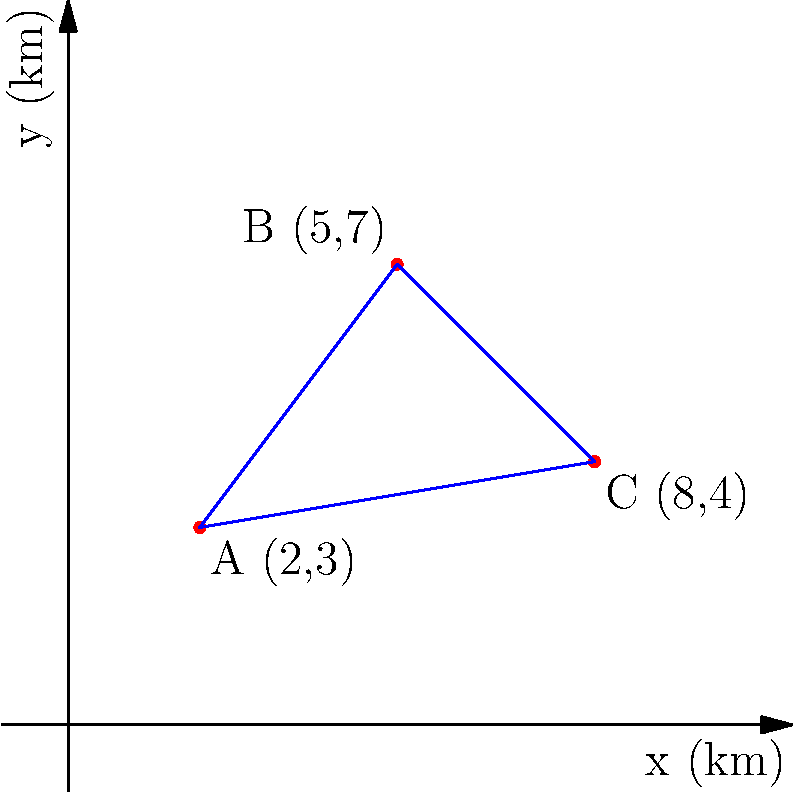Three archaeological sites (A, B, and C) have been discovered in a region of China. Their locations are plotted on a Cartesian coordinate system where each unit represents 1 km. Site A is at (2,3), B at (5,7), and C at (8,4). What is the area of the triangle formed by connecting these three sites, in square kilometers? To find the area of the triangle formed by the three archaeological sites, we can use the formula for the area of a triangle given the coordinates of its vertices:

Area = $\frac{1}{2}|x_1(y_2 - y_3) + x_2(y_3 - y_1) + x_3(y_1 - y_2)|$

Where $(x_1, y_1)$, $(x_2, y_2)$, and $(x_3, y_3)$ are the coordinates of the three vertices.

Step 1: Identify the coordinates
A: $(x_1, y_1) = (2, 3)$
B: $(x_2, y_2) = (5, 7)$
C: $(x_3, y_3) = (8, 4)$

Step 2: Substitute these values into the formula
Area = $\frac{1}{2}|2(7 - 4) + 5(4 - 3) + 8(3 - 7)|$

Step 3: Simplify
Area = $\frac{1}{2}|2(3) + 5(1) + 8(-4)|$
Area = $\frac{1}{2}|6 + 5 - 32|$
Area = $\frac{1}{2}|-21|$
Area = $\frac{1}{2}(21)$
Area = 10.5

Therefore, the area of the triangle formed by the three archaeological sites is 10.5 square kilometers.
Answer: 10.5 km² 